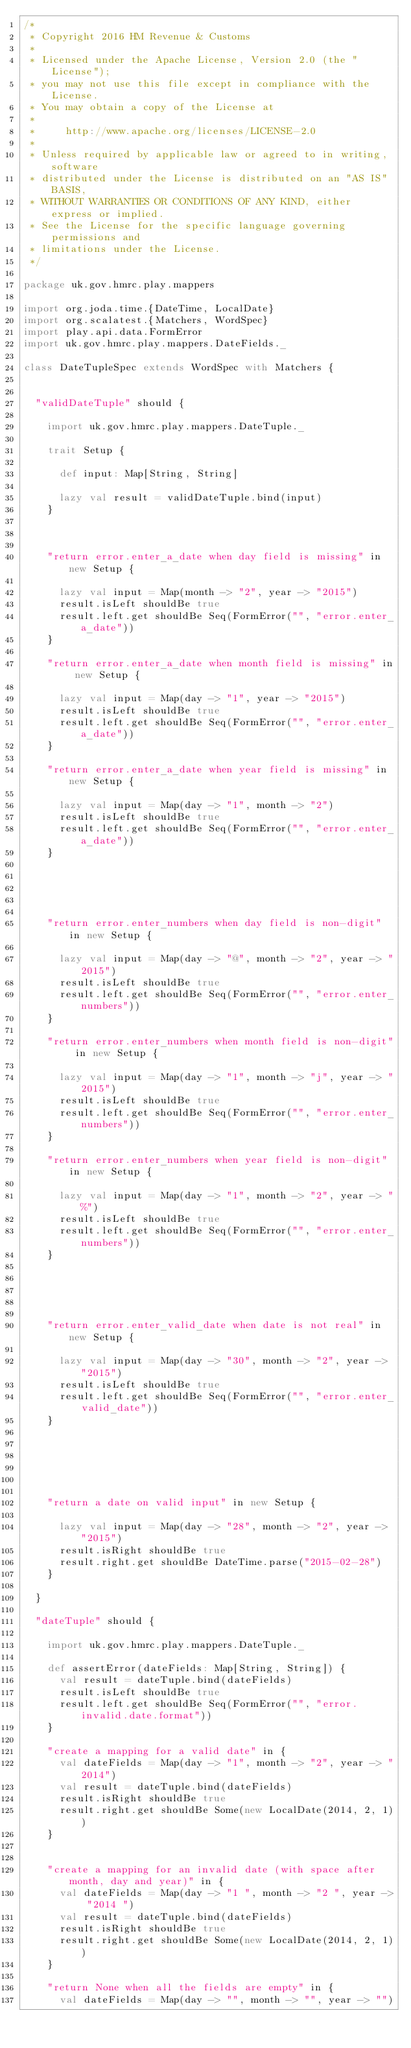<code> <loc_0><loc_0><loc_500><loc_500><_Scala_>/*
 * Copyright 2016 HM Revenue & Customs
 *
 * Licensed under the Apache License, Version 2.0 (the "License");
 * you may not use this file except in compliance with the License.
 * You may obtain a copy of the License at
 *
 *     http://www.apache.org/licenses/LICENSE-2.0
 *
 * Unless required by applicable law or agreed to in writing, software
 * distributed under the License is distributed on an "AS IS" BASIS,
 * WITHOUT WARRANTIES OR CONDITIONS OF ANY KIND, either express or implied.
 * See the License for the specific language governing permissions and
 * limitations under the License.
 */

package uk.gov.hmrc.play.mappers

import org.joda.time.{DateTime, LocalDate}
import org.scalatest.{Matchers, WordSpec}
import play.api.data.FormError
import uk.gov.hmrc.play.mappers.DateFields._

class DateTupleSpec extends WordSpec with Matchers {


  "validDateTuple" should {

    import uk.gov.hmrc.play.mappers.DateTuple._

    trait Setup {

      def input: Map[String, String]

      lazy val result = validDateTuple.bind(input)
    }



    "return error.enter_a_date when day field is missing" in new Setup {

      lazy val input = Map(month -> "2", year -> "2015")
      result.isLeft shouldBe true
      result.left.get shouldBe Seq(FormError("", "error.enter_a_date"))
    }

    "return error.enter_a_date when month field is missing" in new Setup {

      lazy val input = Map(day -> "1", year -> "2015")
      result.isLeft shouldBe true
      result.left.get shouldBe Seq(FormError("", "error.enter_a_date"))
    }

    "return error.enter_a_date when year field is missing" in new Setup {

      lazy val input = Map(day -> "1", month -> "2")
      result.isLeft shouldBe true
      result.left.get shouldBe Seq(FormError("", "error.enter_a_date"))
    }





    "return error.enter_numbers when day field is non-digit" in new Setup {

      lazy val input = Map(day -> "@", month -> "2", year -> "2015")
      result.isLeft shouldBe true
      result.left.get shouldBe Seq(FormError("", "error.enter_numbers"))
    }

    "return error.enter_numbers when month field is non-digit" in new Setup {

      lazy val input = Map(day -> "1", month -> "j", year -> "2015")
      result.isLeft shouldBe true
      result.left.get shouldBe Seq(FormError("", "error.enter_numbers"))
    }

    "return error.enter_numbers when year field is non-digit" in new Setup {

      lazy val input = Map(day -> "1", month -> "2", year -> "%")
      result.isLeft shouldBe true
      result.left.get shouldBe Seq(FormError("", "error.enter_numbers"))
    }





    "return error.enter_valid_date when date is not real" in new Setup {

      lazy val input = Map(day -> "30", month -> "2", year -> "2015")
      result.isLeft shouldBe true
      result.left.get shouldBe Seq(FormError("", "error.enter_valid_date"))
    }






    "return a date on valid input" in new Setup {

      lazy val input = Map(day -> "28", month -> "2", year -> "2015")
      result.isRight shouldBe true
      result.right.get shouldBe DateTime.parse("2015-02-28")
    }

  }

  "dateTuple" should {

    import uk.gov.hmrc.play.mappers.DateTuple._

    def assertError(dateFields: Map[String, String]) {
      val result = dateTuple.bind(dateFields)
      result.isLeft shouldBe true
      result.left.get shouldBe Seq(FormError("", "error.invalid.date.format"))
    }

    "create a mapping for a valid date" in {
      val dateFields = Map(day -> "1", month -> "2", year -> "2014")
      val result = dateTuple.bind(dateFields)
      result.isRight shouldBe true
      result.right.get shouldBe Some(new LocalDate(2014, 2, 1))
    }


    "create a mapping for an invalid date (with space after month, day and year)" in {
      val dateFields = Map(day -> "1 ", month -> "2 ", year -> "2014 ")
      val result = dateTuple.bind(dateFields)
      result.isRight shouldBe true
      result.right.get shouldBe Some(new LocalDate(2014, 2, 1))
    }

    "return None when all the fields are empty" in {
      val dateFields = Map(day -> "", month -> "", year -> "")</code> 